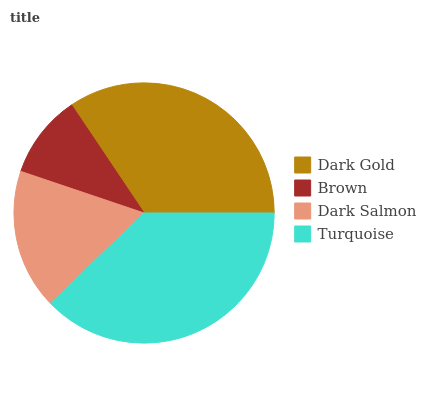Is Brown the minimum?
Answer yes or no. Yes. Is Turquoise the maximum?
Answer yes or no. Yes. Is Dark Salmon the minimum?
Answer yes or no. No. Is Dark Salmon the maximum?
Answer yes or no. No. Is Dark Salmon greater than Brown?
Answer yes or no. Yes. Is Brown less than Dark Salmon?
Answer yes or no. Yes. Is Brown greater than Dark Salmon?
Answer yes or no. No. Is Dark Salmon less than Brown?
Answer yes or no. No. Is Dark Gold the high median?
Answer yes or no. Yes. Is Dark Salmon the low median?
Answer yes or no. Yes. Is Dark Salmon the high median?
Answer yes or no. No. Is Brown the low median?
Answer yes or no. No. 